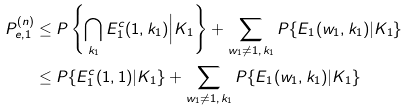<formula> <loc_0><loc_0><loc_500><loc_500>P _ { e , 1 } ^ { ( n ) } & \leq P \left \{ \bigcap _ { k _ { 1 } } E _ { 1 } ^ { c } ( 1 , k _ { 1 } ) \Big | K _ { 1 } \right \} + \sum _ { w _ { 1 } \neq 1 , \, k _ { 1 } } P \{ E _ { 1 } ( w _ { 1 } , k _ { 1 } ) | K _ { 1 } \} \\ & \leq P \{ E _ { 1 } ^ { c } ( 1 , 1 ) | K _ { 1 } \} + \sum _ { w _ { 1 } \neq 1 , \, k _ { 1 } } P \{ E _ { 1 } ( w _ { 1 } , k _ { 1 } ) | K _ { 1 } \}</formula> 